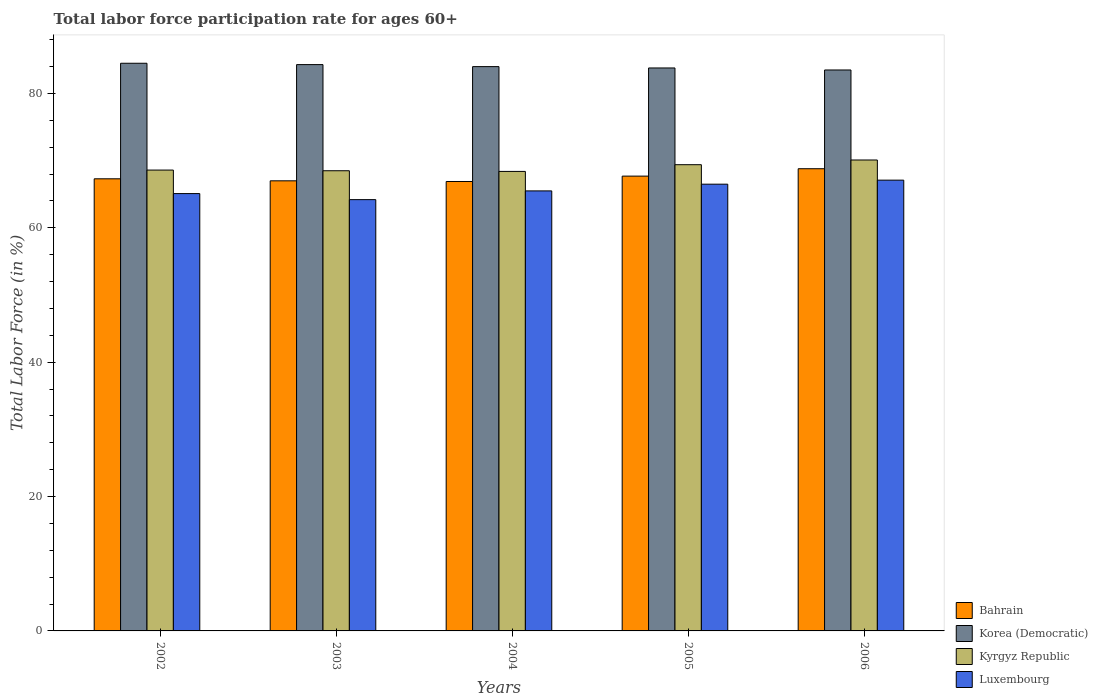How many different coloured bars are there?
Provide a succinct answer. 4. How many groups of bars are there?
Make the answer very short. 5. Are the number of bars per tick equal to the number of legend labels?
Offer a very short reply. Yes. Are the number of bars on each tick of the X-axis equal?
Your response must be concise. Yes. How many bars are there on the 3rd tick from the right?
Ensure brevity in your answer.  4. In how many cases, is the number of bars for a given year not equal to the number of legend labels?
Offer a terse response. 0. What is the labor force participation rate in Luxembourg in 2005?
Ensure brevity in your answer.  66.5. Across all years, what is the maximum labor force participation rate in Bahrain?
Ensure brevity in your answer.  68.8. Across all years, what is the minimum labor force participation rate in Korea (Democratic)?
Your answer should be very brief. 83.5. What is the total labor force participation rate in Kyrgyz Republic in the graph?
Your response must be concise. 345. What is the difference between the labor force participation rate in Bahrain in 2003 and that in 2005?
Offer a terse response. -0.7. What is the difference between the labor force participation rate in Korea (Democratic) in 2003 and the labor force participation rate in Bahrain in 2002?
Provide a succinct answer. 17. What is the average labor force participation rate in Kyrgyz Republic per year?
Offer a terse response. 69. In the year 2005, what is the difference between the labor force participation rate in Bahrain and labor force participation rate in Luxembourg?
Give a very brief answer. 1.2. What is the ratio of the labor force participation rate in Luxembourg in 2003 to that in 2006?
Offer a terse response. 0.96. Is the labor force participation rate in Kyrgyz Republic in 2005 less than that in 2006?
Give a very brief answer. Yes. What is the difference between the highest and the second highest labor force participation rate in Kyrgyz Republic?
Offer a very short reply. 0.7. What is the difference between the highest and the lowest labor force participation rate in Bahrain?
Provide a succinct answer. 1.9. In how many years, is the labor force participation rate in Kyrgyz Republic greater than the average labor force participation rate in Kyrgyz Republic taken over all years?
Keep it short and to the point. 2. Is the sum of the labor force participation rate in Korea (Democratic) in 2003 and 2005 greater than the maximum labor force participation rate in Kyrgyz Republic across all years?
Your response must be concise. Yes. What does the 2nd bar from the left in 2003 represents?
Ensure brevity in your answer.  Korea (Democratic). What does the 2nd bar from the right in 2002 represents?
Offer a very short reply. Kyrgyz Republic. Is it the case that in every year, the sum of the labor force participation rate in Kyrgyz Republic and labor force participation rate in Korea (Democratic) is greater than the labor force participation rate in Bahrain?
Provide a succinct answer. Yes. How many bars are there?
Provide a short and direct response. 20. Does the graph contain any zero values?
Make the answer very short. No. Where does the legend appear in the graph?
Ensure brevity in your answer.  Bottom right. What is the title of the graph?
Keep it short and to the point. Total labor force participation rate for ages 60+. Does "Uruguay" appear as one of the legend labels in the graph?
Give a very brief answer. No. What is the label or title of the X-axis?
Make the answer very short. Years. What is the label or title of the Y-axis?
Your answer should be compact. Total Labor Force (in %). What is the Total Labor Force (in %) of Bahrain in 2002?
Ensure brevity in your answer.  67.3. What is the Total Labor Force (in %) in Korea (Democratic) in 2002?
Provide a succinct answer. 84.5. What is the Total Labor Force (in %) of Kyrgyz Republic in 2002?
Give a very brief answer. 68.6. What is the Total Labor Force (in %) of Luxembourg in 2002?
Offer a very short reply. 65.1. What is the Total Labor Force (in %) of Korea (Democratic) in 2003?
Ensure brevity in your answer.  84.3. What is the Total Labor Force (in %) in Kyrgyz Republic in 2003?
Keep it short and to the point. 68.5. What is the Total Labor Force (in %) of Luxembourg in 2003?
Make the answer very short. 64.2. What is the Total Labor Force (in %) of Bahrain in 2004?
Provide a succinct answer. 66.9. What is the Total Labor Force (in %) in Kyrgyz Republic in 2004?
Make the answer very short. 68.4. What is the Total Labor Force (in %) in Luxembourg in 2004?
Your response must be concise. 65.5. What is the Total Labor Force (in %) in Bahrain in 2005?
Offer a very short reply. 67.7. What is the Total Labor Force (in %) in Korea (Democratic) in 2005?
Provide a succinct answer. 83.8. What is the Total Labor Force (in %) of Kyrgyz Republic in 2005?
Keep it short and to the point. 69.4. What is the Total Labor Force (in %) of Luxembourg in 2005?
Keep it short and to the point. 66.5. What is the Total Labor Force (in %) in Bahrain in 2006?
Give a very brief answer. 68.8. What is the Total Labor Force (in %) in Korea (Democratic) in 2006?
Offer a very short reply. 83.5. What is the Total Labor Force (in %) of Kyrgyz Republic in 2006?
Your response must be concise. 70.1. What is the Total Labor Force (in %) of Luxembourg in 2006?
Make the answer very short. 67.1. Across all years, what is the maximum Total Labor Force (in %) of Bahrain?
Your answer should be very brief. 68.8. Across all years, what is the maximum Total Labor Force (in %) in Korea (Democratic)?
Your answer should be compact. 84.5. Across all years, what is the maximum Total Labor Force (in %) in Kyrgyz Republic?
Ensure brevity in your answer.  70.1. Across all years, what is the maximum Total Labor Force (in %) in Luxembourg?
Make the answer very short. 67.1. Across all years, what is the minimum Total Labor Force (in %) of Bahrain?
Your answer should be very brief. 66.9. Across all years, what is the minimum Total Labor Force (in %) of Korea (Democratic)?
Offer a very short reply. 83.5. Across all years, what is the minimum Total Labor Force (in %) in Kyrgyz Republic?
Your answer should be compact. 68.4. Across all years, what is the minimum Total Labor Force (in %) in Luxembourg?
Make the answer very short. 64.2. What is the total Total Labor Force (in %) of Bahrain in the graph?
Provide a short and direct response. 337.7. What is the total Total Labor Force (in %) in Korea (Democratic) in the graph?
Your answer should be very brief. 420.1. What is the total Total Labor Force (in %) in Kyrgyz Republic in the graph?
Make the answer very short. 345. What is the total Total Labor Force (in %) of Luxembourg in the graph?
Your answer should be compact. 328.4. What is the difference between the Total Labor Force (in %) in Bahrain in 2002 and that in 2003?
Make the answer very short. 0.3. What is the difference between the Total Labor Force (in %) in Bahrain in 2002 and that in 2004?
Your response must be concise. 0.4. What is the difference between the Total Labor Force (in %) of Korea (Democratic) in 2002 and that in 2005?
Provide a short and direct response. 0.7. What is the difference between the Total Labor Force (in %) of Kyrgyz Republic in 2002 and that in 2005?
Your answer should be compact. -0.8. What is the difference between the Total Labor Force (in %) in Luxembourg in 2002 and that in 2005?
Your response must be concise. -1.4. What is the difference between the Total Labor Force (in %) in Korea (Democratic) in 2002 and that in 2006?
Make the answer very short. 1. What is the difference between the Total Labor Force (in %) in Luxembourg in 2002 and that in 2006?
Keep it short and to the point. -2. What is the difference between the Total Labor Force (in %) in Bahrain in 2003 and that in 2004?
Ensure brevity in your answer.  0.1. What is the difference between the Total Labor Force (in %) in Kyrgyz Republic in 2003 and that in 2004?
Provide a succinct answer. 0.1. What is the difference between the Total Labor Force (in %) in Bahrain in 2003 and that in 2005?
Your answer should be compact. -0.7. What is the difference between the Total Labor Force (in %) of Korea (Democratic) in 2003 and that in 2005?
Provide a succinct answer. 0.5. What is the difference between the Total Labor Force (in %) in Kyrgyz Republic in 2003 and that in 2005?
Your answer should be compact. -0.9. What is the difference between the Total Labor Force (in %) in Luxembourg in 2003 and that in 2006?
Your answer should be very brief. -2.9. What is the difference between the Total Labor Force (in %) in Bahrain in 2004 and that in 2005?
Provide a short and direct response. -0.8. What is the difference between the Total Labor Force (in %) of Korea (Democratic) in 2004 and that in 2005?
Your answer should be compact. 0.2. What is the difference between the Total Labor Force (in %) in Luxembourg in 2004 and that in 2005?
Make the answer very short. -1. What is the difference between the Total Labor Force (in %) of Bahrain in 2004 and that in 2006?
Make the answer very short. -1.9. What is the difference between the Total Labor Force (in %) in Korea (Democratic) in 2004 and that in 2006?
Your answer should be compact. 0.5. What is the difference between the Total Labor Force (in %) in Kyrgyz Republic in 2004 and that in 2006?
Your answer should be very brief. -1.7. What is the difference between the Total Labor Force (in %) of Luxembourg in 2004 and that in 2006?
Provide a succinct answer. -1.6. What is the difference between the Total Labor Force (in %) in Bahrain in 2005 and that in 2006?
Give a very brief answer. -1.1. What is the difference between the Total Labor Force (in %) in Korea (Democratic) in 2005 and that in 2006?
Provide a succinct answer. 0.3. What is the difference between the Total Labor Force (in %) in Kyrgyz Republic in 2005 and that in 2006?
Your answer should be very brief. -0.7. What is the difference between the Total Labor Force (in %) in Luxembourg in 2005 and that in 2006?
Provide a short and direct response. -0.6. What is the difference between the Total Labor Force (in %) of Bahrain in 2002 and the Total Labor Force (in %) of Kyrgyz Republic in 2003?
Your answer should be very brief. -1.2. What is the difference between the Total Labor Force (in %) of Bahrain in 2002 and the Total Labor Force (in %) of Luxembourg in 2003?
Your answer should be compact. 3.1. What is the difference between the Total Labor Force (in %) of Korea (Democratic) in 2002 and the Total Labor Force (in %) of Kyrgyz Republic in 2003?
Your answer should be very brief. 16. What is the difference between the Total Labor Force (in %) of Korea (Democratic) in 2002 and the Total Labor Force (in %) of Luxembourg in 2003?
Make the answer very short. 20.3. What is the difference between the Total Labor Force (in %) of Kyrgyz Republic in 2002 and the Total Labor Force (in %) of Luxembourg in 2003?
Give a very brief answer. 4.4. What is the difference between the Total Labor Force (in %) of Bahrain in 2002 and the Total Labor Force (in %) of Korea (Democratic) in 2004?
Make the answer very short. -16.7. What is the difference between the Total Labor Force (in %) in Bahrain in 2002 and the Total Labor Force (in %) in Kyrgyz Republic in 2004?
Give a very brief answer. -1.1. What is the difference between the Total Labor Force (in %) in Bahrain in 2002 and the Total Labor Force (in %) in Luxembourg in 2004?
Keep it short and to the point. 1.8. What is the difference between the Total Labor Force (in %) of Korea (Democratic) in 2002 and the Total Labor Force (in %) of Kyrgyz Republic in 2004?
Your response must be concise. 16.1. What is the difference between the Total Labor Force (in %) in Korea (Democratic) in 2002 and the Total Labor Force (in %) in Luxembourg in 2004?
Ensure brevity in your answer.  19. What is the difference between the Total Labor Force (in %) of Bahrain in 2002 and the Total Labor Force (in %) of Korea (Democratic) in 2005?
Provide a succinct answer. -16.5. What is the difference between the Total Labor Force (in %) in Bahrain in 2002 and the Total Labor Force (in %) in Luxembourg in 2005?
Provide a succinct answer. 0.8. What is the difference between the Total Labor Force (in %) in Korea (Democratic) in 2002 and the Total Labor Force (in %) in Kyrgyz Republic in 2005?
Your answer should be compact. 15.1. What is the difference between the Total Labor Force (in %) in Kyrgyz Republic in 2002 and the Total Labor Force (in %) in Luxembourg in 2005?
Your response must be concise. 2.1. What is the difference between the Total Labor Force (in %) of Bahrain in 2002 and the Total Labor Force (in %) of Korea (Democratic) in 2006?
Make the answer very short. -16.2. What is the difference between the Total Labor Force (in %) in Korea (Democratic) in 2002 and the Total Labor Force (in %) in Kyrgyz Republic in 2006?
Offer a terse response. 14.4. What is the difference between the Total Labor Force (in %) in Korea (Democratic) in 2002 and the Total Labor Force (in %) in Luxembourg in 2006?
Provide a succinct answer. 17.4. What is the difference between the Total Labor Force (in %) of Kyrgyz Republic in 2002 and the Total Labor Force (in %) of Luxembourg in 2006?
Offer a very short reply. 1.5. What is the difference between the Total Labor Force (in %) of Bahrain in 2003 and the Total Labor Force (in %) of Korea (Democratic) in 2004?
Your answer should be very brief. -17. What is the difference between the Total Labor Force (in %) in Bahrain in 2003 and the Total Labor Force (in %) in Kyrgyz Republic in 2004?
Provide a short and direct response. -1.4. What is the difference between the Total Labor Force (in %) of Bahrain in 2003 and the Total Labor Force (in %) of Luxembourg in 2004?
Make the answer very short. 1.5. What is the difference between the Total Labor Force (in %) in Korea (Democratic) in 2003 and the Total Labor Force (in %) in Luxembourg in 2004?
Provide a succinct answer. 18.8. What is the difference between the Total Labor Force (in %) of Bahrain in 2003 and the Total Labor Force (in %) of Korea (Democratic) in 2005?
Your answer should be compact. -16.8. What is the difference between the Total Labor Force (in %) of Bahrain in 2003 and the Total Labor Force (in %) of Korea (Democratic) in 2006?
Provide a short and direct response. -16.5. What is the difference between the Total Labor Force (in %) in Bahrain in 2003 and the Total Labor Force (in %) in Kyrgyz Republic in 2006?
Give a very brief answer. -3.1. What is the difference between the Total Labor Force (in %) in Bahrain in 2003 and the Total Labor Force (in %) in Luxembourg in 2006?
Keep it short and to the point. -0.1. What is the difference between the Total Labor Force (in %) in Korea (Democratic) in 2003 and the Total Labor Force (in %) in Luxembourg in 2006?
Keep it short and to the point. 17.2. What is the difference between the Total Labor Force (in %) of Bahrain in 2004 and the Total Labor Force (in %) of Korea (Democratic) in 2005?
Your response must be concise. -16.9. What is the difference between the Total Labor Force (in %) of Bahrain in 2004 and the Total Labor Force (in %) of Kyrgyz Republic in 2005?
Ensure brevity in your answer.  -2.5. What is the difference between the Total Labor Force (in %) of Bahrain in 2004 and the Total Labor Force (in %) of Luxembourg in 2005?
Keep it short and to the point. 0.4. What is the difference between the Total Labor Force (in %) of Kyrgyz Republic in 2004 and the Total Labor Force (in %) of Luxembourg in 2005?
Your response must be concise. 1.9. What is the difference between the Total Labor Force (in %) in Bahrain in 2004 and the Total Labor Force (in %) in Korea (Democratic) in 2006?
Give a very brief answer. -16.6. What is the difference between the Total Labor Force (in %) in Bahrain in 2004 and the Total Labor Force (in %) in Luxembourg in 2006?
Your response must be concise. -0.2. What is the difference between the Total Labor Force (in %) in Kyrgyz Republic in 2004 and the Total Labor Force (in %) in Luxembourg in 2006?
Your response must be concise. 1.3. What is the difference between the Total Labor Force (in %) of Bahrain in 2005 and the Total Labor Force (in %) of Korea (Democratic) in 2006?
Your answer should be compact. -15.8. What is the difference between the Total Labor Force (in %) of Bahrain in 2005 and the Total Labor Force (in %) of Kyrgyz Republic in 2006?
Ensure brevity in your answer.  -2.4. What is the difference between the Total Labor Force (in %) of Korea (Democratic) in 2005 and the Total Labor Force (in %) of Luxembourg in 2006?
Your response must be concise. 16.7. What is the difference between the Total Labor Force (in %) of Kyrgyz Republic in 2005 and the Total Labor Force (in %) of Luxembourg in 2006?
Ensure brevity in your answer.  2.3. What is the average Total Labor Force (in %) in Bahrain per year?
Your answer should be compact. 67.54. What is the average Total Labor Force (in %) of Korea (Democratic) per year?
Your answer should be compact. 84.02. What is the average Total Labor Force (in %) in Luxembourg per year?
Ensure brevity in your answer.  65.68. In the year 2002, what is the difference between the Total Labor Force (in %) of Bahrain and Total Labor Force (in %) of Korea (Democratic)?
Make the answer very short. -17.2. In the year 2003, what is the difference between the Total Labor Force (in %) in Bahrain and Total Labor Force (in %) in Korea (Democratic)?
Provide a short and direct response. -17.3. In the year 2003, what is the difference between the Total Labor Force (in %) of Bahrain and Total Labor Force (in %) of Luxembourg?
Provide a succinct answer. 2.8. In the year 2003, what is the difference between the Total Labor Force (in %) of Korea (Democratic) and Total Labor Force (in %) of Kyrgyz Republic?
Give a very brief answer. 15.8. In the year 2003, what is the difference between the Total Labor Force (in %) of Korea (Democratic) and Total Labor Force (in %) of Luxembourg?
Ensure brevity in your answer.  20.1. In the year 2003, what is the difference between the Total Labor Force (in %) in Kyrgyz Republic and Total Labor Force (in %) in Luxembourg?
Ensure brevity in your answer.  4.3. In the year 2004, what is the difference between the Total Labor Force (in %) in Bahrain and Total Labor Force (in %) in Korea (Democratic)?
Make the answer very short. -17.1. In the year 2004, what is the difference between the Total Labor Force (in %) of Bahrain and Total Labor Force (in %) of Kyrgyz Republic?
Your response must be concise. -1.5. In the year 2004, what is the difference between the Total Labor Force (in %) in Korea (Democratic) and Total Labor Force (in %) in Kyrgyz Republic?
Give a very brief answer. 15.6. In the year 2004, what is the difference between the Total Labor Force (in %) of Korea (Democratic) and Total Labor Force (in %) of Luxembourg?
Your answer should be compact. 18.5. In the year 2004, what is the difference between the Total Labor Force (in %) of Kyrgyz Republic and Total Labor Force (in %) of Luxembourg?
Keep it short and to the point. 2.9. In the year 2005, what is the difference between the Total Labor Force (in %) of Bahrain and Total Labor Force (in %) of Korea (Democratic)?
Offer a very short reply. -16.1. In the year 2005, what is the difference between the Total Labor Force (in %) of Bahrain and Total Labor Force (in %) of Kyrgyz Republic?
Your answer should be compact. -1.7. In the year 2005, what is the difference between the Total Labor Force (in %) of Bahrain and Total Labor Force (in %) of Luxembourg?
Offer a very short reply. 1.2. In the year 2005, what is the difference between the Total Labor Force (in %) in Korea (Democratic) and Total Labor Force (in %) in Kyrgyz Republic?
Ensure brevity in your answer.  14.4. In the year 2005, what is the difference between the Total Labor Force (in %) of Korea (Democratic) and Total Labor Force (in %) of Luxembourg?
Your answer should be compact. 17.3. In the year 2005, what is the difference between the Total Labor Force (in %) of Kyrgyz Republic and Total Labor Force (in %) of Luxembourg?
Your answer should be very brief. 2.9. In the year 2006, what is the difference between the Total Labor Force (in %) of Bahrain and Total Labor Force (in %) of Korea (Democratic)?
Provide a succinct answer. -14.7. In the year 2006, what is the difference between the Total Labor Force (in %) in Bahrain and Total Labor Force (in %) in Kyrgyz Republic?
Give a very brief answer. -1.3. In the year 2006, what is the difference between the Total Labor Force (in %) in Bahrain and Total Labor Force (in %) in Luxembourg?
Your answer should be very brief. 1.7. In the year 2006, what is the difference between the Total Labor Force (in %) of Korea (Democratic) and Total Labor Force (in %) of Luxembourg?
Offer a very short reply. 16.4. What is the ratio of the Total Labor Force (in %) in Kyrgyz Republic in 2002 to that in 2003?
Offer a terse response. 1. What is the ratio of the Total Labor Force (in %) in Bahrain in 2002 to that in 2004?
Offer a terse response. 1.01. What is the ratio of the Total Labor Force (in %) of Korea (Democratic) in 2002 to that in 2004?
Offer a terse response. 1.01. What is the ratio of the Total Labor Force (in %) of Bahrain in 2002 to that in 2005?
Your answer should be compact. 0.99. What is the ratio of the Total Labor Force (in %) of Korea (Democratic) in 2002 to that in 2005?
Provide a short and direct response. 1.01. What is the ratio of the Total Labor Force (in %) in Luxembourg in 2002 to that in 2005?
Offer a terse response. 0.98. What is the ratio of the Total Labor Force (in %) of Bahrain in 2002 to that in 2006?
Provide a succinct answer. 0.98. What is the ratio of the Total Labor Force (in %) in Kyrgyz Republic in 2002 to that in 2006?
Give a very brief answer. 0.98. What is the ratio of the Total Labor Force (in %) of Luxembourg in 2002 to that in 2006?
Your answer should be compact. 0.97. What is the ratio of the Total Labor Force (in %) of Kyrgyz Republic in 2003 to that in 2004?
Make the answer very short. 1. What is the ratio of the Total Labor Force (in %) in Luxembourg in 2003 to that in 2004?
Your answer should be very brief. 0.98. What is the ratio of the Total Labor Force (in %) in Bahrain in 2003 to that in 2005?
Make the answer very short. 0.99. What is the ratio of the Total Labor Force (in %) of Korea (Democratic) in 2003 to that in 2005?
Keep it short and to the point. 1.01. What is the ratio of the Total Labor Force (in %) of Luxembourg in 2003 to that in 2005?
Offer a terse response. 0.97. What is the ratio of the Total Labor Force (in %) in Bahrain in 2003 to that in 2006?
Provide a short and direct response. 0.97. What is the ratio of the Total Labor Force (in %) of Korea (Democratic) in 2003 to that in 2006?
Your answer should be compact. 1.01. What is the ratio of the Total Labor Force (in %) of Kyrgyz Republic in 2003 to that in 2006?
Make the answer very short. 0.98. What is the ratio of the Total Labor Force (in %) of Luxembourg in 2003 to that in 2006?
Provide a succinct answer. 0.96. What is the ratio of the Total Labor Force (in %) in Kyrgyz Republic in 2004 to that in 2005?
Provide a succinct answer. 0.99. What is the ratio of the Total Labor Force (in %) in Luxembourg in 2004 to that in 2005?
Offer a terse response. 0.98. What is the ratio of the Total Labor Force (in %) of Bahrain in 2004 to that in 2006?
Your response must be concise. 0.97. What is the ratio of the Total Labor Force (in %) of Korea (Democratic) in 2004 to that in 2006?
Give a very brief answer. 1.01. What is the ratio of the Total Labor Force (in %) of Kyrgyz Republic in 2004 to that in 2006?
Give a very brief answer. 0.98. What is the ratio of the Total Labor Force (in %) of Luxembourg in 2004 to that in 2006?
Your answer should be compact. 0.98. What is the ratio of the Total Labor Force (in %) of Bahrain in 2005 to that in 2006?
Offer a very short reply. 0.98. What is the difference between the highest and the second highest Total Labor Force (in %) in Bahrain?
Offer a terse response. 1.1. What is the difference between the highest and the second highest Total Labor Force (in %) of Kyrgyz Republic?
Your response must be concise. 0.7. What is the difference between the highest and the lowest Total Labor Force (in %) in Korea (Democratic)?
Provide a succinct answer. 1. What is the difference between the highest and the lowest Total Labor Force (in %) in Kyrgyz Republic?
Your response must be concise. 1.7. 